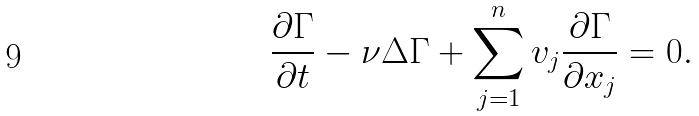<formula> <loc_0><loc_0><loc_500><loc_500>\frac { \partial \Gamma } { \partial t } - \nu \Delta \Gamma + \sum _ { j = 1 } ^ { n } v _ { j } \frac { \partial \Gamma } { \partial x _ { j } } = 0 .</formula> 